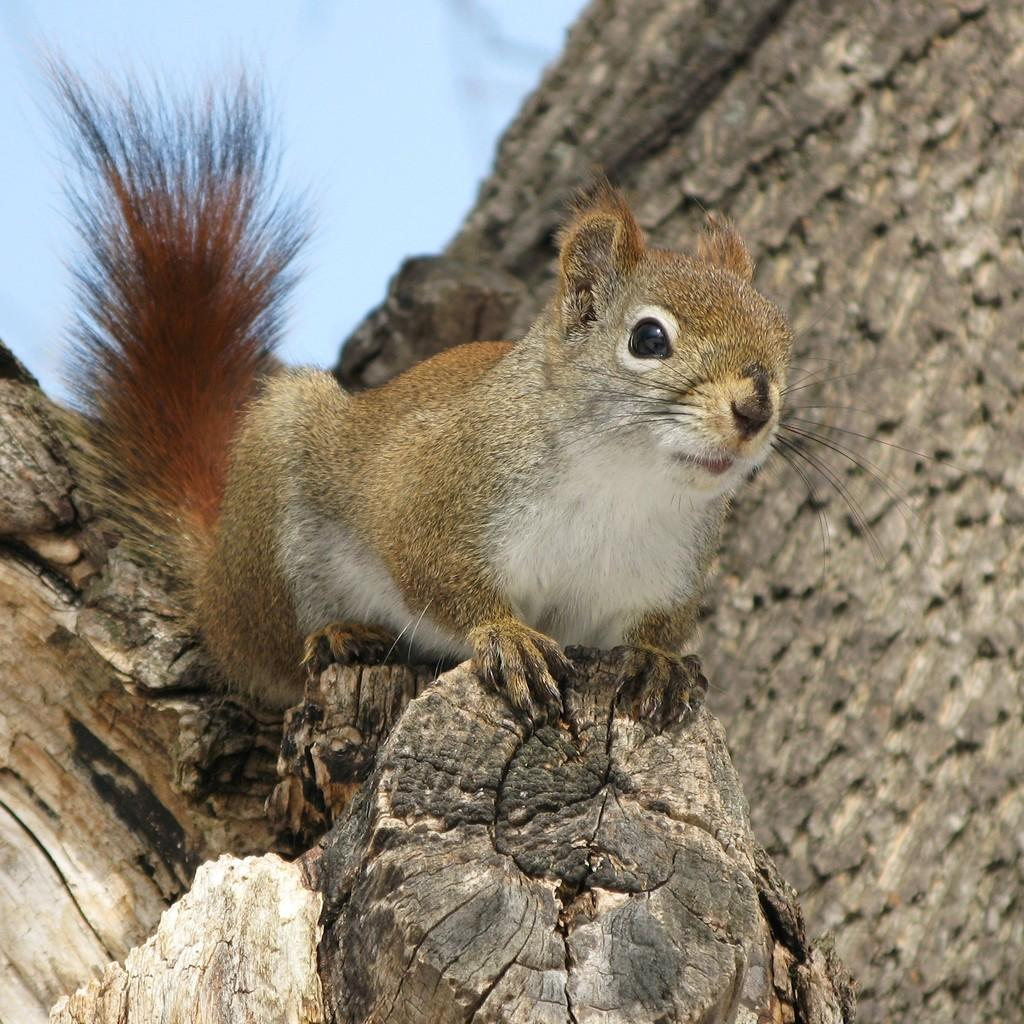What type of animal is in the image? There is a fox squirrel in the image. Where is the fox squirrel located? The fox squirrel is on a wooden trunk. What can be seen at the top of the image? The sky is visible at the top of the image. What type of bit is the fox squirrel using to write in the image? There is no bit present in the image, as the fox squirrel is not writing or using any tools. 